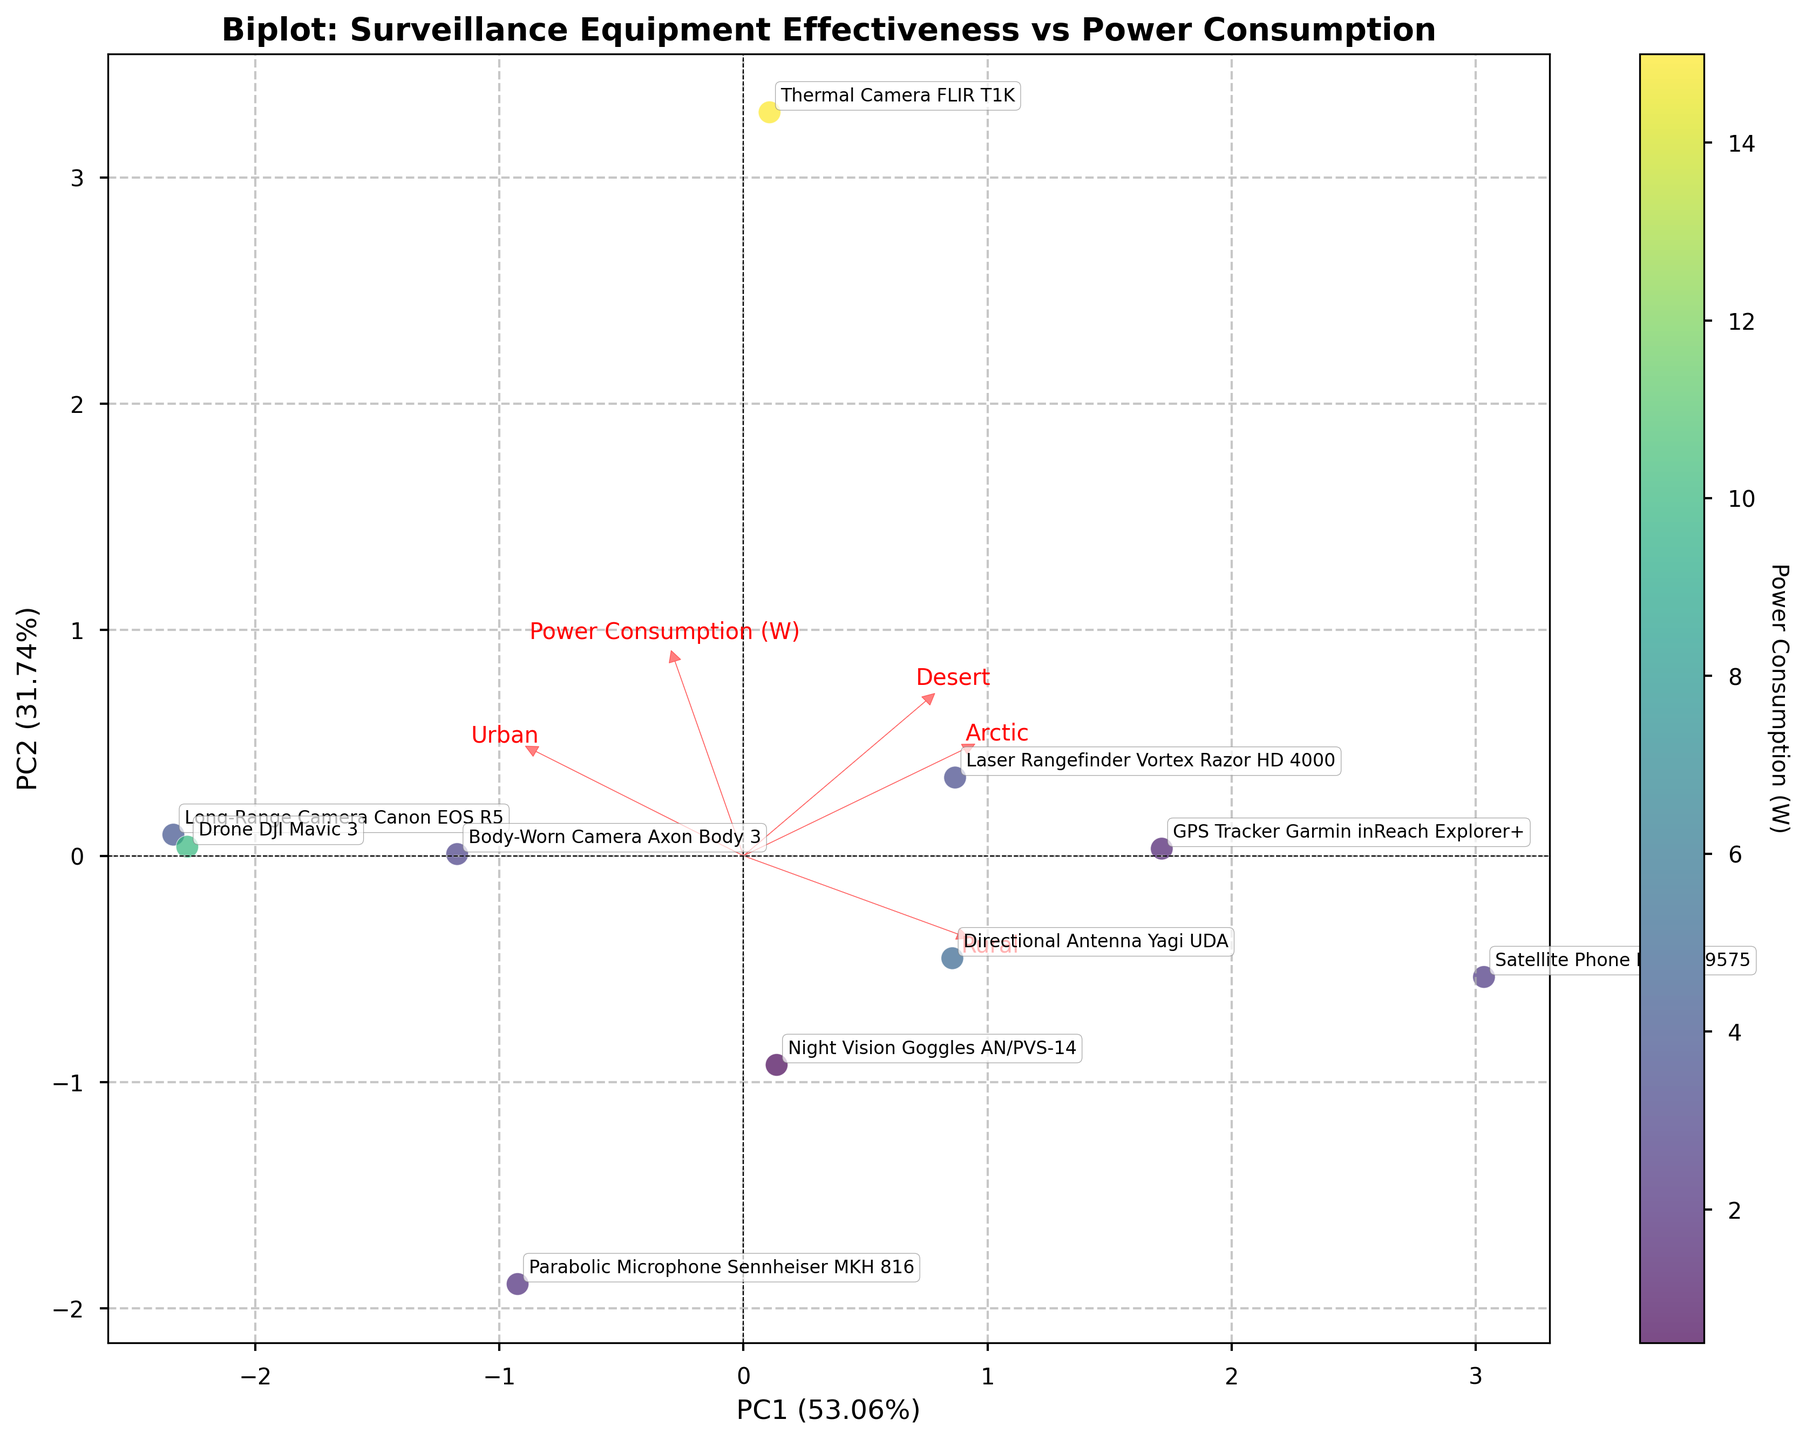What is the title of the plot? The title is located at the top of the plot and provides a summary of what the graph presents.
Answer: Biplot: Surveillance Equipment Effectiveness vs Power Consumption Which equipment has the highest effectiveness in the Urban environment? Look at the label for Urban on the loading arrows and find the equipment closest to that direction.
Answer: Long-Range Camera Canon EOS R5 What is the main color used to represent the points, and what does it signify? The color scheme is shown in the color bar and indicates what values it represents. The points themselves are shaded according to this color.
Answer: A gradient from yellow to purple representing Power Consumption (W) Which surveillance equipment consumes the least power? Identify the point with the lightest color representing the smallest number on the color bar.
Answer: Night Vision Goggles AN/PVS-14 How does the Power Consumption vector compare to the Rural vector in terms of direction? Look at the direction in which both vectors are pointing relative to the origin. Compare their angles.
Answer: The Power Consumption vector points somewhat opposite to the Rural vector Which equipment is most effective in the Desert environment? Find the loadings arrow labeled Desert and see which equipment is closest to that arrow.
Answer: Thermal Camera FLIR T1K Compare the effectiveness of the Thermal Camera FLIR T1K in the Urban and Arctic environments. Find the positions of the equipment relative to the Urban and Arctic vectors. Compare how far in the direction of these arrows the equipment lies.
Answer: Slightly more effective in the Desert How are the GPS Tracker Garmin inReach Explorer+ and the Directional Antenna Yagi UDA similar or different in terms of power consumption and effectiveness across environments? Compare the positions on the plot and their color, which indicates power consumption. Examine distances relative to environment vectors.
Answer: Similar effectiveness, different power consumption; Garmin inReach Explorer+ uses less power Which two types of equipment exhibit similar effectiveness in the Arctic environment but differ significantly in power consumption? Look at the Directional loads and compare the positions of all equipment along the Arctic vector and then observe the color differences.
Answer: Satellite Phone Iridium 9575 and Body-Worn Camera Axon Body 3 